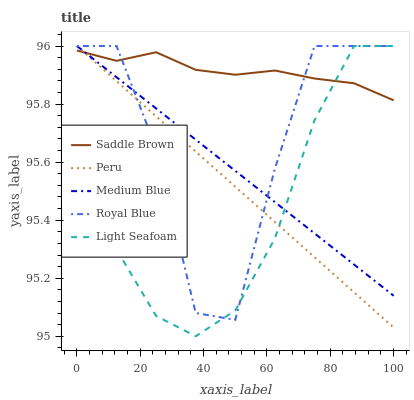Does Light Seafoam have the minimum area under the curve?
Answer yes or no. Yes. Does Saddle Brown have the maximum area under the curve?
Answer yes or no. Yes. Does Medium Blue have the minimum area under the curve?
Answer yes or no. No. Does Medium Blue have the maximum area under the curve?
Answer yes or no. No. Is Medium Blue the smoothest?
Answer yes or no. Yes. Is Royal Blue the roughest?
Answer yes or no. Yes. Is Light Seafoam the smoothest?
Answer yes or no. No. Is Light Seafoam the roughest?
Answer yes or no. No. Does Light Seafoam have the lowest value?
Answer yes or no. Yes. Does Medium Blue have the lowest value?
Answer yes or no. No. Does Peru have the highest value?
Answer yes or no. Yes. Does Saddle Brown have the highest value?
Answer yes or no. No. Does Light Seafoam intersect Saddle Brown?
Answer yes or no. Yes. Is Light Seafoam less than Saddle Brown?
Answer yes or no. No. Is Light Seafoam greater than Saddle Brown?
Answer yes or no. No. 